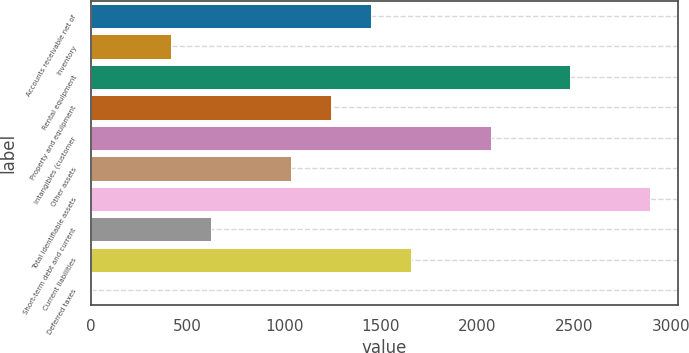Convert chart. <chart><loc_0><loc_0><loc_500><loc_500><bar_chart><fcel>Accounts receivable net of<fcel>Inventory<fcel>Rental equipment<fcel>Property and equipment<fcel>Intangibles (customer<fcel>Other assets<fcel>Total identifiable assets<fcel>Short-term debt and current<fcel>Current liabilities<fcel>Deferred taxes<nl><fcel>1448.8<fcel>416.8<fcel>2480.8<fcel>1242.4<fcel>2068<fcel>1036<fcel>2893.6<fcel>623.2<fcel>1655.2<fcel>4<nl></chart> 